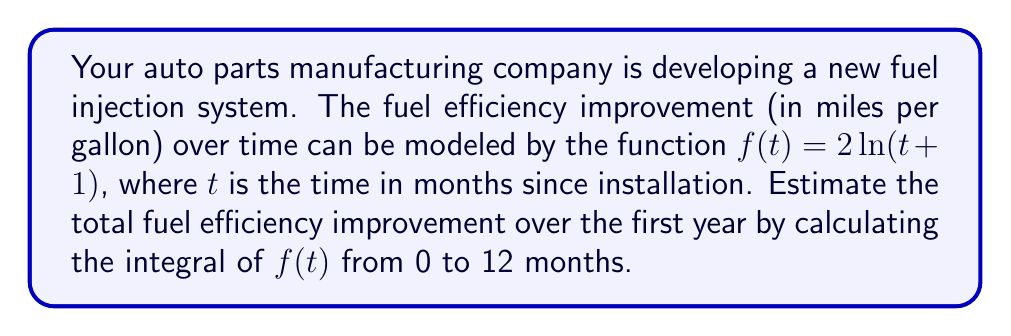Help me with this question. To estimate the total fuel efficiency improvement over the first year, we need to calculate the definite integral of $f(t) = 2\ln(t+1)$ from $t=0$ to $t=12$.

Step 1: Set up the integral
$$\int_0^{12} 2\ln(t+1) dt$$

Step 2: Use integration by parts
Let $u = \ln(t+1)$ and $dv = 2dt$
Then $du = \frac{1}{t+1}dt$ and $v = 2t$

$$\int 2\ln(t+1) dt = 2t\ln(t+1) - \int \frac{2t}{t+1} dt$$

Step 3: Evaluate the second integral
$$\int \frac{2t}{t+1} dt = 2\int (1 - \frac{1}{t+1}) dt = 2t - 2\ln(t+1) + C$$

Step 4: Combine results
$$2t\ln(t+1) - (2t - 2\ln(t+1)) + C = 2t\ln(t+1) - 2t + 2\ln(t+1) + C$$

Step 5: Apply the limits of integration
$$[2t\ln(t+1) - 2t + 2\ln(t+1)]_0^{12}$$

$$= (24\ln(13) - 24 + 2\ln(13)) - (0 - 0 + 0)$$
$$= 26\ln(13) - 24$$

Step 6: Calculate the final value
$$26\ln(13) - 24 \approx 43.76$$
Answer: 43.76 mpg 